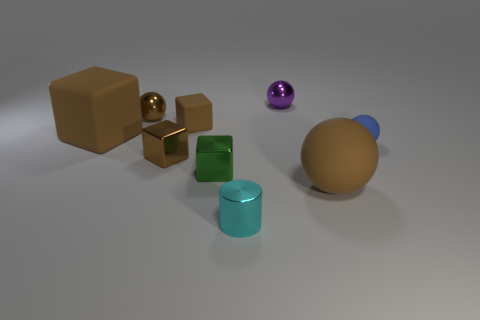Subtract all tiny matte balls. How many balls are left? 3 Subtract all purple balls. How many balls are left? 3 Subtract 3 spheres. How many spheres are left? 1 Add 1 blue metal spheres. How many objects exist? 10 Subtract all cylinders. How many objects are left? 8 Subtract all blue rubber objects. Subtract all green shiny things. How many objects are left? 7 Add 3 small cyan cylinders. How many small cyan cylinders are left? 4 Add 3 tiny purple matte blocks. How many tiny purple matte blocks exist? 3 Subtract 0 red cubes. How many objects are left? 9 Subtract all red cylinders. Subtract all brown blocks. How many cylinders are left? 1 